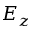Convert formula to latex. <formula><loc_0><loc_0><loc_500><loc_500>E _ { z }</formula> 